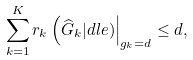Convert formula to latex. <formula><loc_0><loc_0><loc_500><loc_500>\sum _ { k = 1 } ^ { K } r _ { k } \left ( \widehat { G } _ { k } | d l e ) \right | _ { g _ { k } = d } \leq d ,</formula> 